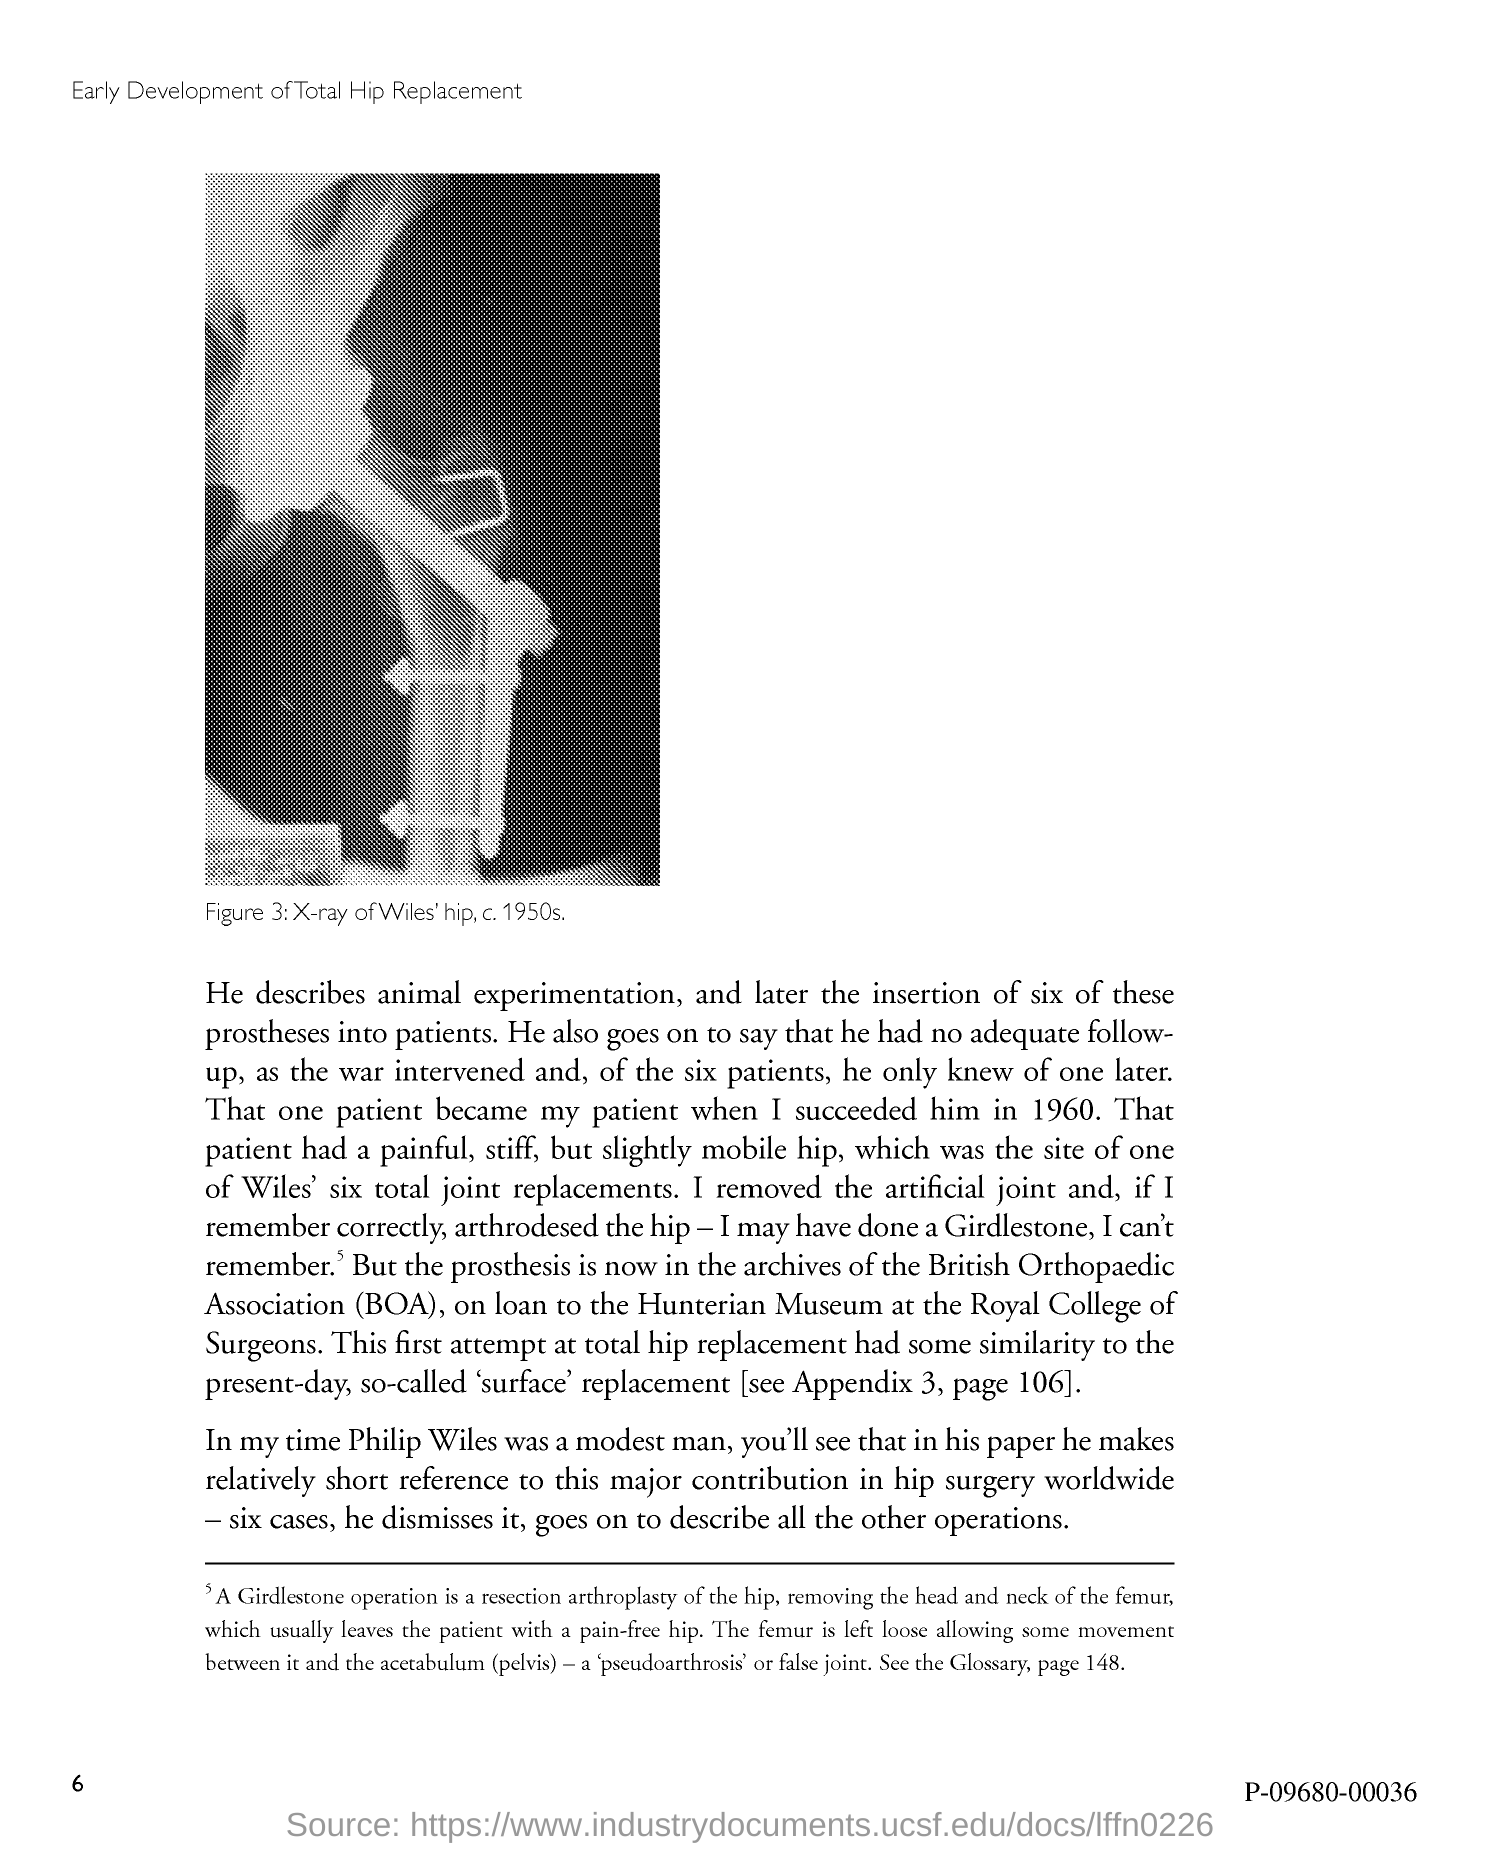What is the number at bottom left of the page?
Your response must be concise. 6. 